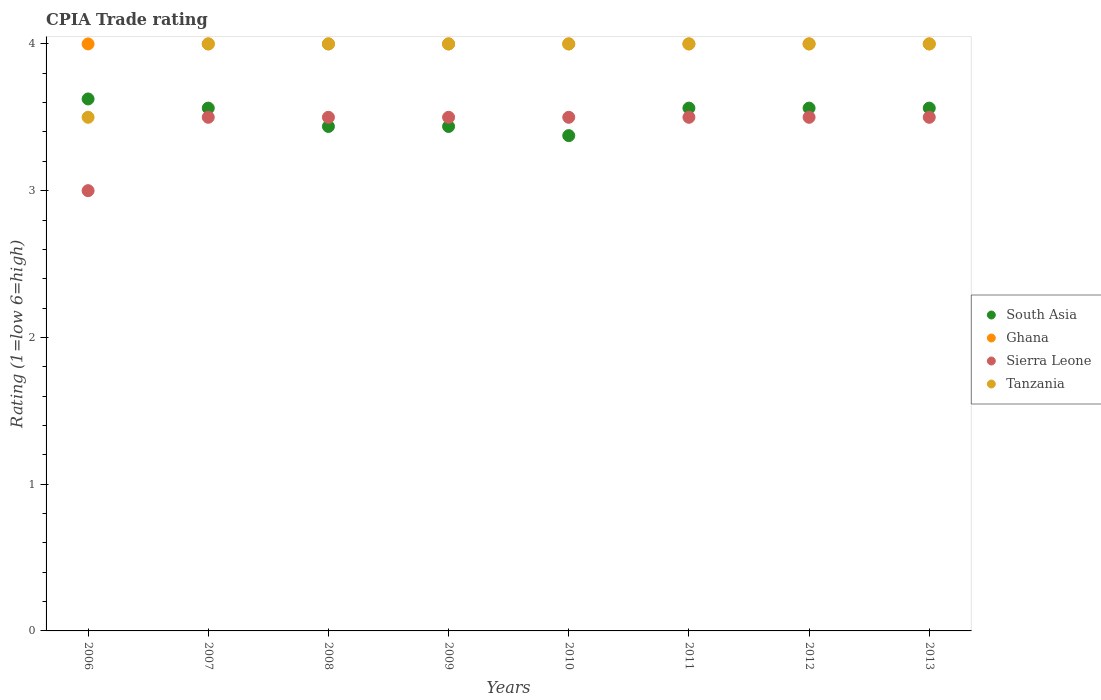How many different coloured dotlines are there?
Ensure brevity in your answer.  4. Is the number of dotlines equal to the number of legend labels?
Give a very brief answer. Yes. What is the CPIA rating in Tanzania in 2007?
Make the answer very short. 4. Across all years, what is the maximum CPIA rating in South Asia?
Offer a very short reply. 3.62. What is the total CPIA rating in Ghana in the graph?
Offer a very short reply. 32. What is the difference between the CPIA rating in Ghana in 2013 and the CPIA rating in Sierra Leone in 2012?
Provide a short and direct response. 0.5. What is the average CPIA rating in South Asia per year?
Your response must be concise. 3.52. What is the ratio of the CPIA rating in Tanzania in 2009 to that in 2010?
Keep it short and to the point. 1. What is the difference between the highest and the second highest CPIA rating in Tanzania?
Provide a succinct answer. 0. In how many years, is the CPIA rating in Tanzania greater than the average CPIA rating in Tanzania taken over all years?
Offer a very short reply. 7. Is the sum of the CPIA rating in South Asia in 2011 and 2013 greater than the maximum CPIA rating in Ghana across all years?
Your response must be concise. Yes. Is it the case that in every year, the sum of the CPIA rating in Ghana and CPIA rating in Tanzania  is greater than the CPIA rating in South Asia?
Offer a terse response. Yes. Does the CPIA rating in Ghana monotonically increase over the years?
Offer a terse response. No. Is the CPIA rating in South Asia strictly greater than the CPIA rating in Ghana over the years?
Provide a short and direct response. No. Is the CPIA rating in Ghana strictly less than the CPIA rating in Tanzania over the years?
Your response must be concise. No. How many legend labels are there?
Offer a very short reply. 4. How are the legend labels stacked?
Your answer should be very brief. Vertical. What is the title of the graph?
Give a very brief answer. CPIA Trade rating. What is the Rating (1=low 6=high) in South Asia in 2006?
Give a very brief answer. 3.62. What is the Rating (1=low 6=high) of Ghana in 2006?
Offer a terse response. 4. What is the Rating (1=low 6=high) of Tanzania in 2006?
Offer a terse response. 3.5. What is the Rating (1=low 6=high) of South Asia in 2007?
Ensure brevity in your answer.  3.56. What is the Rating (1=low 6=high) of South Asia in 2008?
Provide a succinct answer. 3.44. What is the Rating (1=low 6=high) of Ghana in 2008?
Offer a terse response. 4. What is the Rating (1=low 6=high) in Tanzania in 2008?
Provide a succinct answer. 4. What is the Rating (1=low 6=high) of South Asia in 2009?
Provide a short and direct response. 3.44. What is the Rating (1=low 6=high) of Sierra Leone in 2009?
Provide a short and direct response. 3.5. What is the Rating (1=low 6=high) in Tanzania in 2009?
Give a very brief answer. 4. What is the Rating (1=low 6=high) in South Asia in 2010?
Give a very brief answer. 3.38. What is the Rating (1=low 6=high) in Ghana in 2010?
Offer a very short reply. 4. What is the Rating (1=low 6=high) in Sierra Leone in 2010?
Offer a terse response. 3.5. What is the Rating (1=low 6=high) in Tanzania in 2010?
Provide a succinct answer. 4. What is the Rating (1=low 6=high) in South Asia in 2011?
Your answer should be very brief. 3.56. What is the Rating (1=low 6=high) of Tanzania in 2011?
Provide a short and direct response. 4. What is the Rating (1=low 6=high) of South Asia in 2012?
Give a very brief answer. 3.56. What is the Rating (1=low 6=high) in Tanzania in 2012?
Ensure brevity in your answer.  4. What is the Rating (1=low 6=high) of South Asia in 2013?
Provide a short and direct response. 3.56. What is the Rating (1=low 6=high) of Ghana in 2013?
Your answer should be compact. 4. What is the Rating (1=low 6=high) of Sierra Leone in 2013?
Offer a terse response. 3.5. Across all years, what is the maximum Rating (1=low 6=high) of South Asia?
Provide a succinct answer. 3.62. Across all years, what is the maximum Rating (1=low 6=high) in Ghana?
Your answer should be compact. 4. Across all years, what is the minimum Rating (1=low 6=high) in South Asia?
Offer a very short reply. 3.38. Across all years, what is the minimum Rating (1=low 6=high) of Ghana?
Your answer should be very brief. 4. Across all years, what is the minimum Rating (1=low 6=high) of Tanzania?
Offer a very short reply. 3.5. What is the total Rating (1=low 6=high) of South Asia in the graph?
Provide a succinct answer. 28.12. What is the total Rating (1=low 6=high) of Sierra Leone in the graph?
Your response must be concise. 27.5. What is the total Rating (1=low 6=high) in Tanzania in the graph?
Make the answer very short. 31.5. What is the difference between the Rating (1=low 6=high) in South Asia in 2006 and that in 2007?
Keep it short and to the point. 0.06. What is the difference between the Rating (1=low 6=high) in Ghana in 2006 and that in 2007?
Give a very brief answer. 0. What is the difference between the Rating (1=low 6=high) of Tanzania in 2006 and that in 2007?
Give a very brief answer. -0.5. What is the difference between the Rating (1=low 6=high) in South Asia in 2006 and that in 2008?
Give a very brief answer. 0.19. What is the difference between the Rating (1=low 6=high) of Ghana in 2006 and that in 2008?
Give a very brief answer. 0. What is the difference between the Rating (1=low 6=high) of Sierra Leone in 2006 and that in 2008?
Give a very brief answer. -0.5. What is the difference between the Rating (1=low 6=high) of South Asia in 2006 and that in 2009?
Offer a terse response. 0.19. What is the difference between the Rating (1=low 6=high) of Ghana in 2006 and that in 2009?
Offer a terse response. 0. What is the difference between the Rating (1=low 6=high) in Tanzania in 2006 and that in 2009?
Your response must be concise. -0.5. What is the difference between the Rating (1=low 6=high) in Tanzania in 2006 and that in 2010?
Offer a terse response. -0.5. What is the difference between the Rating (1=low 6=high) in South Asia in 2006 and that in 2011?
Make the answer very short. 0.06. What is the difference between the Rating (1=low 6=high) in Tanzania in 2006 and that in 2011?
Offer a terse response. -0.5. What is the difference between the Rating (1=low 6=high) in South Asia in 2006 and that in 2012?
Your answer should be compact. 0.06. What is the difference between the Rating (1=low 6=high) in Tanzania in 2006 and that in 2012?
Ensure brevity in your answer.  -0.5. What is the difference between the Rating (1=low 6=high) in South Asia in 2006 and that in 2013?
Your answer should be very brief. 0.06. What is the difference between the Rating (1=low 6=high) in Sierra Leone in 2007 and that in 2008?
Your answer should be compact. 0. What is the difference between the Rating (1=low 6=high) of Tanzania in 2007 and that in 2008?
Your answer should be compact. 0. What is the difference between the Rating (1=low 6=high) of South Asia in 2007 and that in 2009?
Give a very brief answer. 0.12. What is the difference between the Rating (1=low 6=high) of Ghana in 2007 and that in 2009?
Your response must be concise. 0. What is the difference between the Rating (1=low 6=high) of South Asia in 2007 and that in 2010?
Your response must be concise. 0.19. What is the difference between the Rating (1=low 6=high) of Sierra Leone in 2007 and that in 2010?
Your answer should be compact. 0. What is the difference between the Rating (1=low 6=high) in Sierra Leone in 2007 and that in 2012?
Your answer should be very brief. 0. What is the difference between the Rating (1=low 6=high) of Tanzania in 2007 and that in 2012?
Ensure brevity in your answer.  0. What is the difference between the Rating (1=low 6=high) in South Asia in 2007 and that in 2013?
Offer a very short reply. 0. What is the difference between the Rating (1=low 6=high) in Ghana in 2007 and that in 2013?
Offer a very short reply. 0. What is the difference between the Rating (1=low 6=high) of Sierra Leone in 2007 and that in 2013?
Offer a terse response. 0. What is the difference between the Rating (1=low 6=high) in Tanzania in 2007 and that in 2013?
Give a very brief answer. 0. What is the difference between the Rating (1=low 6=high) of South Asia in 2008 and that in 2009?
Provide a succinct answer. 0. What is the difference between the Rating (1=low 6=high) in Ghana in 2008 and that in 2009?
Your answer should be compact. 0. What is the difference between the Rating (1=low 6=high) of Sierra Leone in 2008 and that in 2009?
Your response must be concise. 0. What is the difference between the Rating (1=low 6=high) in Tanzania in 2008 and that in 2009?
Your response must be concise. 0. What is the difference between the Rating (1=low 6=high) in South Asia in 2008 and that in 2010?
Your answer should be very brief. 0.06. What is the difference between the Rating (1=low 6=high) of Ghana in 2008 and that in 2010?
Provide a short and direct response. 0. What is the difference between the Rating (1=low 6=high) of South Asia in 2008 and that in 2011?
Your response must be concise. -0.12. What is the difference between the Rating (1=low 6=high) in South Asia in 2008 and that in 2012?
Keep it short and to the point. -0.12. What is the difference between the Rating (1=low 6=high) in Tanzania in 2008 and that in 2012?
Ensure brevity in your answer.  0. What is the difference between the Rating (1=low 6=high) of South Asia in 2008 and that in 2013?
Make the answer very short. -0.12. What is the difference between the Rating (1=low 6=high) in Sierra Leone in 2008 and that in 2013?
Your response must be concise. 0. What is the difference between the Rating (1=low 6=high) of South Asia in 2009 and that in 2010?
Your answer should be compact. 0.06. What is the difference between the Rating (1=low 6=high) in Tanzania in 2009 and that in 2010?
Your answer should be compact. 0. What is the difference between the Rating (1=low 6=high) in South Asia in 2009 and that in 2011?
Ensure brevity in your answer.  -0.12. What is the difference between the Rating (1=low 6=high) of Sierra Leone in 2009 and that in 2011?
Ensure brevity in your answer.  0. What is the difference between the Rating (1=low 6=high) in Tanzania in 2009 and that in 2011?
Ensure brevity in your answer.  0. What is the difference between the Rating (1=low 6=high) of South Asia in 2009 and that in 2012?
Your answer should be very brief. -0.12. What is the difference between the Rating (1=low 6=high) in Tanzania in 2009 and that in 2012?
Offer a terse response. 0. What is the difference between the Rating (1=low 6=high) of South Asia in 2009 and that in 2013?
Provide a short and direct response. -0.12. What is the difference between the Rating (1=low 6=high) of South Asia in 2010 and that in 2011?
Offer a terse response. -0.19. What is the difference between the Rating (1=low 6=high) in Tanzania in 2010 and that in 2011?
Your answer should be very brief. 0. What is the difference between the Rating (1=low 6=high) in South Asia in 2010 and that in 2012?
Offer a very short reply. -0.19. What is the difference between the Rating (1=low 6=high) in Sierra Leone in 2010 and that in 2012?
Provide a succinct answer. 0. What is the difference between the Rating (1=low 6=high) of South Asia in 2010 and that in 2013?
Provide a succinct answer. -0.19. What is the difference between the Rating (1=low 6=high) in Ghana in 2010 and that in 2013?
Ensure brevity in your answer.  0. What is the difference between the Rating (1=low 6=high) of Sierra Leone in 2010 and that in 2013?
Provide a short and direct response. 0. What is the difference between the Rating (1=low 6=high) of South Asia in 2011 and that in 2012?
Your answer should be very brief. 0. What is the difference between the Rating (1=low 6=high) of Sierra Leone in 2011 and that in 2013?
Provide a succinct answer. 0. What is the difference between the Rating (1=low 6=high) in Tanzania in 2011 and that in 2013?
Make the answer very short. 0. What is the difference between the Rating (1=low 6=high) in Tanzania in 2012 and that in 2013?
Your response must be concise. 0. What is the difference between the Rating (1=low 6=high) in South Asia in 2006 and the Rating (1=low 6=high) in Ghana in 2007?
Provide a succinct answer. -0.38. What is the difference between the Rating (1=low 6=high) in South Asia in 2006 and the Rating (1=low 6=high) in Tanzania in 2007?
Keep it short and to the point. -0.38. What is the difference between the Rating (1=low 6=high) in South Asia in 2006 and the Rating (1=low 6=high) in Ghana in 2008?
Give a very brief answer. -0.38. What is the difference between the Rating (1=low 6=high) in South Asia in 2006 and the Rating (1=low 6=high) in Sierra Leone in 2008?
Your answer should be compact. 0.12. What is the difference between the Rating (1=low 6=high) in South Asia in 2006 and the Rating (1=low 6=high) in Tanzania in 2008?
Ensure brevity in your answer.  -0.38. What is the difference between the Rating (1=low 6=high) in Ghana in 2006 and the Rating (1=low 6=high) in Sierra Leone in 2008?
Offer a terse response. 0.5. What is the difference between the Rating (1=low 6=high) in South Asia in 2006 and the Rating (1=low 6=high) in Ghana in 2009?
Make the answer very short. -0.38. What is the difference between the Rating (1=low 6=high) in South Asia in 2006 and the Rating (1=low 6=high) in Sierra Leone in 2009?
Give a very brief answer. 0.12. What is the difference between the Rating (1=low 6=high) in South Asia in 2006 and the Rating (1=low 6=high) in Tanzania in 2009?
Give a very brief answer. -0.38. What is the difference between the Rating (1=low 6=high) in South Asia in 2006 and the Rating (1=low 6=high) in Ghana in 2010?
Provide a succinct answer. -0.38. What is the difference between the Rating (1=low 6=high) of South Asia in 2006 and the Rating (1=low 6=high) of Tanzania in 2010?
Make the answer very short. -0.38. What is the difference between the Rating (1=low 6=high) in Ghana in 2006 and the Rating (1=low 6=high) in Tanzania in 2010?
Keep it short and to the point. 0. What is the difference between the Rating (1=low 6=high) in South Asia in 2006 and the Rating (1=low 6=high) in Ghana in 2011?
Provide a short and direct response. -0.38. What is the difference between the Rating (1=low 6=high) in South Asia in 2006 and the Rating (1=low 6=high) in Sierra Leone in 2011?
Your response must be concise. 0.12. What is the difference between the Rating (1=low 6=high) of South Asia in 2006 and the Rating (1=low 6=high) of Tanzania in 2011?
Offer a terse response. -0.38. What is the difference between the Rating (1=low 6=high) of Ghana in 2006 and the Rating (1=low 6=high) of Sierra Leone in 2011?
Ensure brevity in your answer.  0.5. What is the difference between the Rating (1=low 6=high) of Ghana in 2006 and the Rating (1=low 6=high) of Tanzania in 2011?
Your response must be concise. 0. What is the difference between the Rating (1=low 6=high) of Sierra Leone in 2006 and the Rating (1=low 6=high) of Tanzania in 2011?
Offer a terse response. -1. What is the difference between the Rating (1=low 6=high) in South Asia in 2006 and the Rating (1=low 6=high) in Ghana in 2012?
Provide a short and direct response. -0.38. What is the difference between the Rating (1=low 6=high) in South Asia in 2006 and the Rating (1=low 6=high) in Sierra Leone in 2012?
Offer a terse response. 0.12. What is the difference between the Rating (1=low 6=high) of South Asia in 2006 and the Rating (1=low 6=high) of Tanzania in 2012?
Provide a succinct answer. -0.38. What is the difference between the Rating (1=low 6=high) of Ghana in 2006 and the Rating (1=low 6=high) of Tanzania in 2012?
Your answer should be very brief. 0. What is the difference between the Rating (1=low 6=high) of Sierra Leone in 2006 and the Rating (1=low 6=high) of Tanzania in 2012?
Make the answer very short. -1. What is the difference between the Rating (1=low 6=high) of South Asia in 2006 and the Rating (1=low 6=high) of Ghana in 2013?
Give a very brief answer. -0.38. What is the difference between the Rating (1=low 6=high) in South Asia in 2006 and the Rating (1=low 6=high) in Tanzania in 2013?
Make the answer very short. -0.38. What is the difference between the Rating (1=low 6=high) in Ghana in 2006 and the Rating (1=low 6=high) in Tanzania in 2013?
Keep it short and to the point. 0. What is the difference between the Rating (1=low 6=high) of Sierra Leone in 2006 and the Rating (1=low 6=high) of Tanzania in 2013?
Your answer should be very brief. -1. What is the difference between the Rating (1=low 6=high) in South Asia in 2007 and the Rating (1=low 6=high) in Ghana in 2008?
Give a very brief answer. -0.44. What is the difference between the Rating (1=low 6=high) in South Asia in 2007 and the Rating (1=low 6=high) in Sierra Leone in 2008?
Provide a succinct answer. 0.06. What is the difference between the Rating (1=low 6=high) of South Asia in 2007 and the Rating (1=low 6=high) of Tanzania in 2008?
Your answer should be compact. -0.44. What is the difference between the Rating (1=low 6=high) of Sierra Leone in 2007 and the Rating (1=low 6=high) of Tanzania in 2008?
Ensure brevity in your answer.  -0.5. What is the difference between the Rating (1=low 6=high) of South Asia in 2007 and the Rating (1=low 6=high) of Ghana in 2009?
Offer a very short reply. -0.44. What is the difference between the Rating (1=low 6=high) in South Asia in 2007 and the Rating (1=low 6=high) in Sierra Leone in 2009?
Your response must be concise. 0.06. What is the difference between the Rating (1=low 6=high) in South Asia in 2007 and the Rating (1=low 6=high) in Tanzania in 2009?
Make the answer very short. -0.44. What is the difference between the Rating (1=low 6=high) of Sierra Leone in 2007 and the Rating (1=low 6=high) of Tanzania in 2009?
Offer a terse response. -0.5. What is the difference between the Rating (1=low 6=high) in South Asia in 2007 and the Rating (1=low 6=high) in Ghana in 2010?
Keep it short and to the point. -0.44. What is the difference between the Rating (1=low 6=high) in South Asia in 2007 and the Rating (1=low 6=high) in Sierra Leone in 2010?
Offer a terse response. 0.06. What is the difference between the Rating (1=low 6=high) in South Asia in 2007 and the Rating (1=low 6=high) in Tanzania in 2010?
Offer a terse response. -0.44. What is the difference between the Rating (1=low 6=high) in Ghana in 2007 and the Rating (1=low 6=high) in Sierra Leone in 2010?
Make the answer very short. 0.5. What is the difference between the Rating (1=low 6=high) of South Asia in 2007 and the Rating (1=low 6=high) of Ghana in 2011?
Provide a succinct answer. -0.44. What is the difference between the Rating (1=low 6=high) of South Asia in 2007 and the Rating (1=low 6=high) of Sierra Leone in 2011?
Offer a very short reply. 0.06. What is the difference between the Rating (1=low 6=high) of South Asia in 2007 and the Rating (1=low 6=high) of Tanzania in 2011?
Provide a succinct answer. -0.44. What is the difference between the Rating (1=low 6=high) in Ghana in 2007 and the Rating (1=low 6=high) in Sierra Leone in 2011?
Give a very brief answer. 0.5. What is the difference between the Rating (1=low 6=high) in Sierra Leone in 2007 and the Rating (1=low 6=high) in Tanzania in 2011?
Your answer should be compact. -0.5. What is the difference between the Rating (1=low 6=high) of South Asia in 2007 and the Rating (1=low 6=high) of Ghana in 2012?
Give a very brief answer. -0.44. What is the difference between the Rating (1=low 6=high) in South Asia in 2007 and the Rating (1=low 6=high) in Sierra Leone in 2012?
Your response must be concise. 0.06. What is the difference between the Rating (1=low 6=high) of South Asia in 2007 and the Rating (1=low 6=high) of Tanzania in 2012?
Your response must be concise. -0.44. What is the difference between the Rating (1=low 6=high) in Ghana in 2007 and the Rating (1=low 6=high) in Sierra Leone in 2012?
Your answer should be compact. 0.5. What is the difference between the Rating (1=low 6=high) in South Asia in 2007 and the Rating (1=low 6=high) in Ghana in 2013?
Keep it short and to the point. -0.44. What is the difference between the Rating (1=low 6=high) of South Asia in 2007 and the Rating (1=low 6=high) of Sierra Leone in 2013?
Ensure brevity in your answer.  0.06. What is the difference between the Rating (1=low 6=high) in South Asia in 2007 and the Rating (1=low 6=high) in Tanzania in 2013?
Offer a very short reply. -0.44. What is the difference between the Rating (1=low 6=high) of Ghana in 2007 and the Rating (1=low 6=high) of Sierra Leone in 2013?
Ensure brevity in your answer.  0.5. What is the difference between the Rating (1=low 6=high) in South Asia in 2008 and the Rating (1=low 6=high) in Ghana in 2009?
Your response must be concise. -0.56. What is the difference between the Rating (1=low 6=high) in South Asia in 2008 and the Rating (1=low 6=high) in Sierra Leone in 2009?
Your response must be concise. -0.06. What is the difference between the Rating (1=low 6=high) of South Asia in 2008 and the Rating (1=low 6=high) of Tanzania in 2009?
Provide a short and direct response. -0.56. What is the difference between the Rating (1=low 6=high) in South Asia in 2008 and the Rating (1=low 6=high) in Ghana in 2010?
Offer a very short reply. -0.56. What is the difference between the Rating (1=low 6=high) of South Asia in 2008 and the Rating (1=low 6=high) of Sierra Leone in 2010?
Provide a succinct answer. -0.06. What is the difference between the Rating (1=low 6=high) in South Asia in 2008 and the Rating (1=low 6=high) in Tanzania in 2010?
Ensure brevity in your answer.  -0.56. What is the difference between the Rating (1=low 6=high) of Ghana in 2008 and the Rating (1=low 6=high) of Sierra Leone in 2010?
Offer a terse response. 0.5. What is the difference between the Rating (1=low 6=high) of Ghana in 2008 and the Rating (1=low 6=high) of Tanzania in 2010?
Give a very brief answer. 0. What is the difference between the Rating (1=low 6=high) in Sierra Leone in 2008 and the Rating (1=low 6=high) in Tanzania in 2010?
Offer a terse response. -0.5. What is the difference between the Rating (1=low 6=high) of South Asia in 2008 and the Rating (1=low 6=high) of Ghana in 2011?
Your response must be concise. -0.56. What is the difference between the Rating (1=low 6=high) in South Asia in 2008 and the Rating (1=low 6=high) in Sierra Leone in 2011?
Make the answer very short. -0.06. What is the difference between the Rating (1=low 6=high) in South Asia in 2008 and the Rating (1=low 6=high) in Tanzania in 2011?
Your answer should be compact. -0.56. What is the difference between the Rating (1=low 6=high) of Ghana in 2008 and the Rating (1=low 6=high) of Sierra Leone in 2011?
Offer a very short reply. 0.5. What is the difference between the Rating (1=low 6=high) of Ghana in 2008 and the Rating (1=low 6=high) of Tanzania in 2011?
Your answer should be very brief. 0. What is the difference between the Rating (1=low 6=high) of South Asia in 2008 and the Rating (1=low 6=high) of Ghana in 2012?
Offer a terse response. -0.56. What is the difference between the Rating (1=low 6=high) in South Asia in 2008 and the Rating (1=low 6=high) in Sierra Leone in 2012?
Make the answer very short. -0.06. What is the difference between the Rating (1=low 6=high) of South Asia in 2008 and the Rating (1=low 6=high) of Tanzania in 2012?
Your answer should be very brief. -0.56. What is the difference between the Rating (1=low 6=high) in Ghana in 2008 and the Rating (1=low 6=high) in Sierra Leone in 2012?
Offer a terse response. 0.5. What is the difference between the Rating (1=low 6=high) of Sierra Leone in 2008 and the Rating (1=low 6=high) of Tanzania in 2012?
Make the answer very short. -0.5. What is the difference between the Rating (1=low 6=high) of South Asia in 2008 and the Rating (1=low 6=high) of Ghana in 2013?
Give a very brief answer. -0.56. What is the difference between the Rating (1=low 6=high) of South Asia in 2008 and the Rating (1=low 6=high) of Sierra Leone in 2013?
Offer a terse response. -0.06. What is the difference between the Rating (1=low 6=high) in South Asia in 2008 and the Rating (1=low 6=high) in Tanzania in 2013?
Give a very brief answer. -0.56. What is the difference between the Rating (1=low 6=high) in Ghana in 2008 and the Rating (1=low 6=high) in Sierra Leone in 2013?
Make the answer very short. 0.5. What is the difference between the Rating (1=low 6=high) of Ghana in 2008 and the Rating (1=low 6=high) of Tanzania in 2013?
Your response must be concise. 0. What is the difference between the Rating (1=low 6=high) in Sierra Leone in 2008 and the Rating (1=low 6=high) in Tanzania in 2013?
Keep it short and to the point. -0.5. What is the difference between the Rating (1=low 6=high) in South Asia in 2009 and the Rating (1=low 6=high) in Ghana in 2010?
Your answer should be very brief. -0.56. What is the difference between the Rating (1=low 6=high) of South Asia in 2009 and the Rating (1=low 6=high) of Sierra Leone in 2010?
Your response must be concise. -0.06. What is the difference between the Rating (1=low 6=high) in South Asia in 2009 and the Rating (1=low 6=high) in Tanzania in 2010?
Your answer should be compact. -0.56. What is the difference between the Rating (1=low 6=high) in Ghana in 2009 and the Rating (1=low 6=high) in Sierra Leone in 2010?
Ensure brevity in your answer.  0.5. What is the difference between the Rating (1=low 6=high) in Ghana in 2009 and the Rating (1=low 6=high) in Tanzania in 2010?
Provide a short and direct response. 0. What is the difference between the Rating (1=low 6=high) in Sierra Leone in 2009 and the Rating (1=low 6=high) in Tanzania in 2010?
Give a very brief answer. -0.5. What is the difference between the Rating (1=low 6=high) in South Asia in 2009 and the Rating (1=low 6=high) in Ghana in 2011?
Offer a very short reply. -0.56. What is the difference between the Rating (1=low 6=high) of South Asia in 2009 and the Rating (1=low 6=high) of Sierra Leone in 2011?
Offer a very short reply. -0.06. What is the difference between the Rating (1=low 6=high) of South Asia in 2009 and the Rating (1=low 6=high) of Tanzania in 2011?
Your response must be concise. -0.56. What is the difference between the Rating (1=low 6=high) in Ghana in 2009 and the Rating (1=low 6=high) in Tanzania in 2011?
Provide a short and direct response. 0. What is the difference between the Rating (1=low 6=high) in Sierra Leone in 2009 and the Rating (1=low 6=high) in Tanzania in 2011?
Give a very brief answer. -0.5. What is the difference between the Rating (1=low 6=high) in South Asia in 2009 and the Rating (1=low 6=high) in Ghana in 2012?
Provide a succinct answer. -0.56. What is the difference between the Rating (1=low 6=high) in South Asia in 2009 and the Rating (1=low 6=high) in Sierra Leone in 2012?
Offer a terse response. -0.06. What is the difference between the Rating (1=low 6=high) of South Asia in 2009 and the Rating (1=low 6=high) of Tanzania in 2012?
Keep it short and to the point. -0.56. What is the difference between the Rating (1=low 6=high) in South Asia in 2009 and the Rating (1=low 6=high) in Ghana in 2013?
Your answer should be compact. -0.56. What is the difference between the Rating (1=low 6=high) of South Asia in 2009 and the Rating (1=low 6=high) of Sierra Leone in 2013?
Your answer should be compact. -0.06. What is the difference between the Rating (1=low 6=high) of South Asia in 2009 and the Rating (1=low 6=high) of Tanzania in 2013?
Offer a terse response. -0.56. What is the difference between the Rating (1=low 6=high) of Ghana in 2009 and the Rating (1=low 6=high) of Sierra Leone in 2013?
Offer a very short reply. 0.5. What is the difference between the Rating (1=low 6=high) in Ghana in 2009 and the Rating (1=low 6=high) in Tanzania in 2013?
Your response must be concise. 0. What is the difference between the Rating (1=low 6=high) in South Asia in 2010 and the Rating (1=low 6=high) in Ghana in 2011?
Provide a short and direct response. -0.62. What is the difference between the Rating (1=low 6=high) of South Asia in 2010 and the Rating (1=low 6=high) of Sierra Leone in 2011?
Make the answer very short. -0.12. What is the difference between the Rating (1=low 6=high) of South Asia in 2010 and the Rating (1=low 6=high) of Tanzania in 2011?
Make the answer very short. -0.62. What is the difference between the Rating (1=low 6=high) of South Asia in 2010 and the Rating (1=low 6=high) of Ghana in 2012?
Make the answer very short. -0.62. What is the difference between the Rating (1=low 6=high) in South Asia in 2010 and the Rating (1=low 6=high) in Sierra Leone in 2012?
Offer a very short reply. -0.12. What is the difference between the Rating (1=low 6=high) of South Asia in 2010 and the Rating (1=low 6=high) of Tanzania in 2012?
Offer a very short reply. -0.62. What is the difference between the Rating (1=low 6=high) in Ghana in 2010 and the Rating (1=low 6=high) in Sierra Leone in 2012?
Ensure brevity in your answer.  0.5. What is the difference between the Rating (1=low 6=high) in Ghana in 2010 and the Rating (1=low 6=high) in Tanzania in 2012?
Your answer should be compact. 0. What is the difference between the Rating (1=low 6=high) in Sierra Leone in 2010 and the Rating (1=low 6=high) in Tanzania in 2012?
Make the answer very short. -0.5. What is the difference between the Rating (1=low 6=high) in South Asia in 2010 and the Rating (1=low 6=high) in Ghana in 2013?
Keep it short and to the point. -0.62. What is the difference between the Rating (1=low 6=high) in South Asia in 2010 and the Rating (1=low 6=high) in Sierra Leone in 2013?
Make the answer very short. -0.12. What is the difference between the Rating (1=low 6=high) of South Asia in 2010 and the Rating (1=low 6=high) of Tanzania in 2013?
Give a very brief answer. -0.62. What is the difference between the Rating (1=low 6=high) in Ghana in 2010 and the Rating (1=low 6=high) in Sierra Leone in 2013?
Provide a short and direct response. 0.5. What is the difference between the Rating (1=low 6=high) of Ghana in 2010 and the Rating (1=low 6=high) of Tanzania in 2013?
Keep it short and to the point. 0. What is the difference between the Rating (1=low 6=high) of Sierra Leone in 2010 and the Rating (1=low 6=high) of Tanzania in 2013?
Your answer should be compact. -0.5. What is the difference between the Rating (1=low 6=high) in South Asia in 2011 and the Rating (1=low 6=high) in Ghana in 2012?
Your answer should be very brief. -0.44. What is the difference between the Rating (1=low 6=high) of South Asia in 2011 and the Rating (1=low 6=high) of Sierra Leone in 2012?
Offer a terse response. 0.06. What is the difference between the Rating (1=low 6=high) in South Asia in 2011 and the Rating (1=low 6=high) in Tanzania in 2012?
Your answer should be compact. -0.44. What is the difference between the Rating (1=low 6=high) in Ghana in 2011 and the Rating (1=low 6=high) in Tanzania in 2012?
Ensure brevity in your answer.  0. What is the difference between the Rating (1=low 6=high) in South Asia in 2011 and the Rating (1=low 6=high) in Ghana in 2013?
Offer a terse response. -0.44. What is the difference between the Rating (1=low 6=high) in South Asia in 2011 and the Rating (1=low 6=high) in Sierra Leone in 2013?
Your answer should be very brief. 0.06. What is the difference between the Rating (1=low 6=high) in South Asia in 2011 and the Rating (1=low 6=high) in Tanzania in 2013?
Give a very brief answer. -0.44. What is the difference between the Rating (1=low 6=high) of Ghana in 2011 and the Rating (1=low 6=high) of Sierra Leone in 2013?
Give a very brief answer. 0.5. What is the difference between the Rating (1=low 6=high) of Sierra Leone in 2011 and the Rating (1=low 6=high) of Tanzania in 2013?
Offer a very short reply. -0.5. What is the difference between the Rating (1=low 6=high) in South Asia in 2012 and the Rating (1=low 6=high) in Ghana in 2013?
Keep it short and to the point. -0.44. What is the difference between the Rating (1=low 6=high) of South Asia in 2012 and the Rating (1=low 6=high) of Sierra Leone in 2013?
Provide a short and direct response. 0.06. What is the difference between the Rating (1=low 6=high) in South Asia in 2012 and the Rating (1=low 6=high) in Tanzania in 2013?
Provide a short and direct response. -0.44. What is the difference between the Rating (1=low 6=high) in Ghana in 2012 and the Rating (1=low 6=high) in Tanzania in 2013?
Make the answer very short. 0. What is the difference between the Rating (1=low 6=high) of Sierra Leone in 2012 and the Rating (1=low 6=high) of Tanzania in 2013?
Ensure brevity in your answer.  -0.5. What is the average Rating (1=low 6=high) of South Asia per year?
Keep it short and to the point. 3.52. What is the average Rating (1=low 6=high) in Sierra Leone per year?
Your answer should be compact. 3.44. What is the average Rating (1=low 6=high) of Tanzania per year?
Your answer should be very brief. 3.94. In the year 2006, what is the difference between the Rating (1=low 6=high) in South Asia and Rating (1=low 6=high) in Ghana?
Your answer should be compact. -0.38. In the year 2006, what is the difference between the Rating (1=low 6=high) of Ghana and Rating (1=low 6=high) of Tanzania?
Your answer should be compact. 0.5. In the year 2006, what is the difference between the Rating (1=low 6=high) in Sierra Leone and Rating (1=low 6=high) in Tanzania?
Offer a terse response. -0.5. In the year 2007, what is the difference between the Rating (1=low 6=high) of South Asia and Rating (1=low 6=high) of Ghana?
Offer a very short reply. -0.44. In the year 2007, what is the difference between the Rating (1=low 6=high) in South Asia and Rating (1=low 6=high) in Sierra Leone?
Give a very brief answer. 0.06. In the year 2007, what is the difference between the Rating (1=low 6=high) of South Asia and Rating (1=low 6=high) of Tanzania?
Your answer should be very brief. -0.44. In the year 2007, what is the difference between the Rating (1=low 6=high) in Ghana and Rating (1=low 6=high) in Tanzania?
Give a very brief answer. 0. In the year 2007, what is the difference between the Rating (1=low 6=high) of Sierra Leone and Rating (1=low 6=high) of Tanzania?
Your answer should be very brief. -0.5. In the year 2008, what is the difference between the Rating (1=low 6=high) of South Asia and Rating (1=low 6=high) of Ghana?
Offer a terse response. -0.56. In the year 2008, what is the difference between the Rating (1=low 6=high) of South Asia and Rating (1=low 6=high) of Sierra Leone?
Give a very brief answer. -0.06. In the year 2008, what is the difference between the Rating (1=low 6=high) of South Asia and Rating (1=low 6=high) of Tanzania?
Your answer should be compact. -0.56. In the year 2009, what is the difference between the Rating (1=low 6=high) in South Asia and Rating (1=low 6=high) in Ghana?
Keep it short and to the point. -0.56. In the year 2009, what is the difference between the Rating (1=low 6=high) of South Asia and Rating (1=low 6=high) of Sierra Leone?
Your answer should be compact. -0.06. In the year 2009, what is the difference between the Rating (1=low 6=high) in South Asia and Rating (1=low 6=high) in Tanzania?
Provide a succinct answer. -0.56. In the year 2009, what is the difference between the Rating (1=low 6=high) of Ghana and Rating (1=low 6=high) of Tanzania?
Keep it short and to the point. 0. In the year 2009, what is the difference between the Rating (1=low 6=high) of Sierra Leone and Rating (1=low 6=high) of Tanzania?
Your answer should be compact. -0.5. In the year 2010, what is the difference between the Rating (1=low 6=high) in South Asia and Rating (1=low 6=high) in Ghana?
Your response must be concise. -0.62. In the year 2010, what is the difference between the Rating (1=low 6=high) in South Asia and Rating (1=low 6=high) in Sierra Leone?
Keep it short and to the point. -0.12. In the year 2010, what is the difference between the Rating (1=low 6=high) of South Asia and Rating (1=low 6=high) of Tanzania?
Make the answer very short. -0.62. In the year 2010, what is the difference between the Rating (1=low 6=high) in Ghana and Rating (1=low 6=high) in Sierra Leone?
Provide a succinct answer. 0.5. In the year 2011, what is the difference between the Rating (1=low 6=high) of South Asia and Rating (1=low 6=high) of Ghana?
Your response must be concise. -0.44. In the year 2011, what is the difference between the Rating (1=low 6=high) in South Asia and Rating (1=low 6=high) in Sierra Leone?
Provide a short and direct response. 0.06. In the year 2011, what is the difference between the Rating (1=low 6=high) in South Asia and Rating (1=low 6=high) in Tanzania?
Provide a short and direct response. -0.44. In the year 2011, what is the difference between the Rating (1=low 6=high) in Ghana and Rating (1=low 6=high) in Tanzania?
Ensure brevity in your answer.  0. In the year 2012, what is the difference between the Rating (1=low 6=high) of South Asia and Rating (1=low 6=high) of Ghana?
Your response must be concise. -0.44. In the year 2012, what is the difference between the Rating (1=low 6=high) of South Asia and Rating (1=low 6=high) of Sierra Leone?
Ensure brevity in your answer.  0.06. In the year 2012, what is the difference between the Rating (1=low 6=high) of South Asia and Rating (1=low 6=high) of Tanzania?
Provide a succinct answer. -0.44. In the year 2012, what is the difference between the Rating (1=low 6=high) in Ghana and Rating (1=low 6=high) in Sierra Leone?
Your response must be concise. 0.5. In the year 2012, what is the difference between the Rating (1=low 6=high) in Ghana and Rating (1=low 6=high) in Tanzania?
Make the answer very short. 0. In the year 2012, what is the difference between the Rating (1=low 6=high) of Sierra Leone and Rating (1=low 6=high) of Tanzania?
Provide a short and direct response. -0.5. In the year 2013, what is the difference between the Rating (1=low 6=high) in South Asia and Rating (1=low 6=high) in Ghana?
Offer a terse response. -0.44. In the year 2013, what is the difference between the Rating (1=low 6=high) in South Asia and Rating (1=low 6=high) in Sierra Leone?
Keep it short and to the point. 0.06. In the year 2013, what is the difference between the Rating (1=low 6=high) in South Asia and Rating (1=low 6=high) in Tanzania?
Keep it short and to the point. -0.44. In the year 2013, what is the difference between the Rating (1=low 6=high) of Ghana and Rating (1=low 6=high) of Tanzania?
Your answer should be compact. 0. In the year 2013, what is the difference between the Rating (1=low 6=high) of Sierra Leone and Rating (1=low 6=high) of Tanzania?
Your response must be concise. -0.5. What is the ratio of the Rating (1=low 6=high) in South Asia in 2006 to that in 2007?
Ensure brevity in your answer.  1.02. What is the ratio of the Rating (1=low 6=high) in Tanzania in 2006 to that in 2007?
Ensure brevity in your answer.  0.88. What is the ratio of the Rating (1=low 6=high) in South Asia in 2006 to that in 2008?
Your response must be concise. 1.05. What is the ratio of the Rating (1=low 6=high) in Ghana in 2006 to that in 2008?
Offer a terse response. 1. What is the ratio of the Rating (1=low 6=high) of Sierra Leone in 2006 to that in 2008?
Make the answer very short. 0.86. What is the ratio of the Rating (1=low 6=high) in South Asia in 2006 to that in 2009?
Keep it short and to the point. 1.05. What is the ratio of the Rating (1=low 6=high) in Ghana in 2006 to that in 2009?
Your answer should be compact. 1. What is the ratio of the Rating (1=low 6=high) of South Asia in 2006 to that in 2010?
Keep it short and to the point. 1.07. What is the ratio of the Rating (1=low 6=high) in Ghana in 2006 to that in 2010?
Ensure brevity in your answer.  1. What is the ratio of the Rating (1=low 6=high) of Sierra Leone in 2006 to that in 2010?
Provide a short and direct response. 0.86. What is the ratio of the Rating (1=low 6=high) of Tanzania in 2006 to that in 2010?
Keep it short and to the point. 0.88. What is the ratio of the Rating (1=low 6=high) in South Asia in 2006 to that in 2011?
Provide a short and direct response. 1.02. What is the ratio of the Rating (1=low 6=high) of Ghana in 2006 to that in 2011?
Provide a succinct answer. 1. What is the ratio of the Rating (1=low 6=high) of Sierra Leone in 2006 to that in 2011?
Ensure brevity in your answer.  0.86. What is the ratio of the Rating (1=low 6=high) in Tanzania in 2006 to that in 2011?
Your answer should be compact. 0.88. What is the ratio of the Rating (1=low 6=high) of South Asia in 2006 to that in 2012?
Ensure brevity in your answer.  1.02. What is the ratio of the Rating (1=low 6=high) of Tanzania in 2006 to that in 2012?
Keep it short and to the point. 0.88. What is the ratio of the Rating (1=low 6=high) in South Asia in 2006 to that in 2013?
Ensure brevity in your answer.  1.02. What is the ratio of the Rating (1=low 6=high) of South Asia in 2007 to that in 2008?
Your answer should be very brief. 1.04. What is the ratio of the Rating (1=low 6=high) in Sierra Leone in 2007 to that in 2008?
Ensure brevity in your answer.  1. What is the ratio of the Rating (1=low 6=high) in Tanzania in 2007 to that in 2008?
Ensure brevity in your answer.  1. What is the ratio of the Rating (1=low 6=high) of South Asia in 2007 to that in 2009?
Make the answer very short. 1.04. What is the ratio of the Rating (1=low 6=high) in Ghana in 2007 to that in 2009?
Keep it short and to the point. 1. What is the ratio of the Rating (1=low 6=high) in Sierra Leone in 2007 to that in 2009?
Keep it short and to the point. 1. What is the ratio of the Rating (1=low 6=high) of South Asia in 2007 to that in 2010?
Offer a terse response. 1.06. What is the ratio of the Rating (1=low 6=high) in Ghana in 2007 to that in 2010?
Your response must be concise. 1. What is the ratio of the Rating (1=low 6=high) in Tanzania in 2007 to that in 2010?
Your answer should be very brief. 1. What is the ratio of the Rating (1=low 6=high) of South Asia in 2007 to that in 2011?
Your answer should be very brief. 1. What is the ratio of the Rating (1=low 6=high) in Ghana in 2007 to that in 2012?
Keep it short and to the point. 1. What is the ratio of the Rating (1=low 6=high) in Tanzania in 2007 to that in 2012?
Offer a terse response. 1. What is the ratio of the Rating (1=low 6=high) of South Asia in 2007 to that in 2013?
Keep it short and to the point. 1. What is the ratio of the Rating (1=low 6=high) of Ghana in 2007 to that in 2013?
Give a very brief answer. 1. What is the ratio of the Rating (1=low 6=high) in South Asia in 2008 to that in 2009?
Keep it short and to the point. 1. What is the ratio of the Rating (1=low 6=high) of Ghana in 2008 to that in 2009?
Offer a very short reply. 1. What is the ratio of the Rating (1=low 6=high) in South Asia in 2008 to that in 2010?
Your response must be concise. 1.02. What is the ratio of the Rating (1=low 6=high) in Ghana in 2008 to that in 2010?
Provide a short and direct response. 1. What is the ratio of the Rating (1=low 6=high) of Sierra Leone in 2008 to that in 2010?
Offer a terse response. 1. What is the ratio of the Rating (1=low 6=high) of Tanzania in 2008 to that in 2010?
Ensure brevity in your answer.  1. What is the ratio of the Rating (1=low 6=high) of South Asia in 2008 to that in 2011?
Your answer should be very brief. 0.96. What is the ratio of the Rating (1=low 6=high) in Sierra Leone in 2008 to that in 2011?
Give a very brief answer. 1. What is the ratio of the Rating (1=low 6=high) of Tanzania in 2008 to that in 2011?
Provide a short and direct response. 1. What is the ratio of the Rating (1=low 6=high) in South Asia in 2008 to that in 2012?
Ensure brevity in your answer.  0.96. What is the ratio of the Rating (1=low 6=high) in South Asia in 2008 to that in 2013?
Offer a very short reply. 0.96. What is the ratio of the Rating (1=low 6=high) of Sierra Leone in 2008 to that in 2013?
Ensure brevity in your answer.  1. What is the ratio of the Rating (1=low 6=high) in Tanzania in 2008 to that in 2013?
Offer a terse response. 1. What is the ratio of the Rating (1=low 6=high) of South Asia in 2009 to that in 2010?
Make the answer very short. 1.02. What is the ratio of the Rating (1=low 6=high) of Ghana in 2009 to that in 2010?
Provide a succinct answer. 1. What is the ratio of the Rating (1=low 6=high) in Tanzania in 2009 to that in 2010?
Offer a terse response. 1. What is the ratio of the Rating (1=low 6=high) in South Asia in 2009 to that in 2011?
Make the answer very short. 0.96. What is the ratio of the Rating (1=low 6=high) of Tanzania in 2009 to that in 2011?
Your answer should be very brief. 1. What is the ratio of the Rating (1=low 6=high) in South Asia in 2009 to that in 2012?
Offer a terse response. 0.96. What is the ratio of the Rating (1=low 6=high) in Ghana in 2009 to that in 2012?
Your answer should be very brief. 1. What is the ratio of the Rating (1=low 6=high) in Tanzania in 2009 to that in 2012?
Your response must be concise. 1. What is the ratio of the Rating (1=low 6=high) in South Asia in 2009 to that in 2013?
Make the answer very short. 0.96. What is the ratio of the Rating (1=low 6=high) of Sierra Leone in 2009 to that in 2013?
Make the answer very short. 1. What is the ratio of the Rating (1=low 6=high) of Sierra Leone in 2010 to that in 2011?
Your response must be concise. 1. What is the ratio of the Rating (1=low 6=high) of Tanzania in 2010 to that in 2011?
Offer a terse response. 1. What is the ratio of the Rating (1=low 6=high) in Sierra Leone in 2010 to that in 2013?
Your response must be concise. 1. What is the ratio of the Rating (1=low 6=high) in Tanzania in 2010 to that in 2013?
Your answer should be very brief. 1. What is the ratio of the Rating (1=low 6=high) of Sierra Leone in 2011 to that in 2013?
Ensure brevity in your answer.  1. What is the ratio of the Rating (1=low 6=high) in South Asia in 2012 to that in 2013?
Keep it short and to the point. 1. What is the ratio of the Rating (1=low 6=high) of Tanzania in 2012 to that in 2013?
Make the answer very short. 1. What is the difference between the highest and the second highest Rating (1=low 6=high) of South Asia?
Keep it short and to the point. 0.06. What is the difference between the highest and the lowest Rating (1=low 6=high) of South Asia?
Provide a short and direct response. 0.25. What is the difference between the highest and the lowest Rating (1=low 6=high) of Ghana?
Keep it short and to the point. 0. What is the difference between the highest and the lowest Rating (1=low 6=high) in Sierra Leone?
Keep it short and to the point. 0.5. 